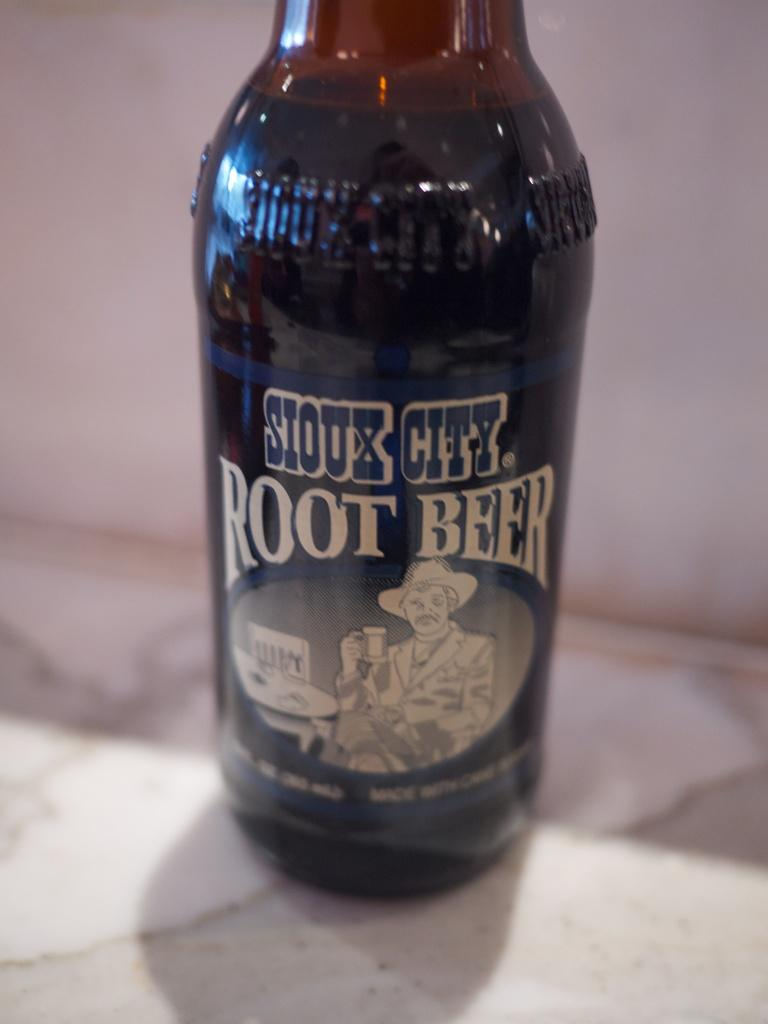<image>
Offer a succinct explanation of the picture presented. A bottle of Sioux City Root Beer sits on a shelf. 